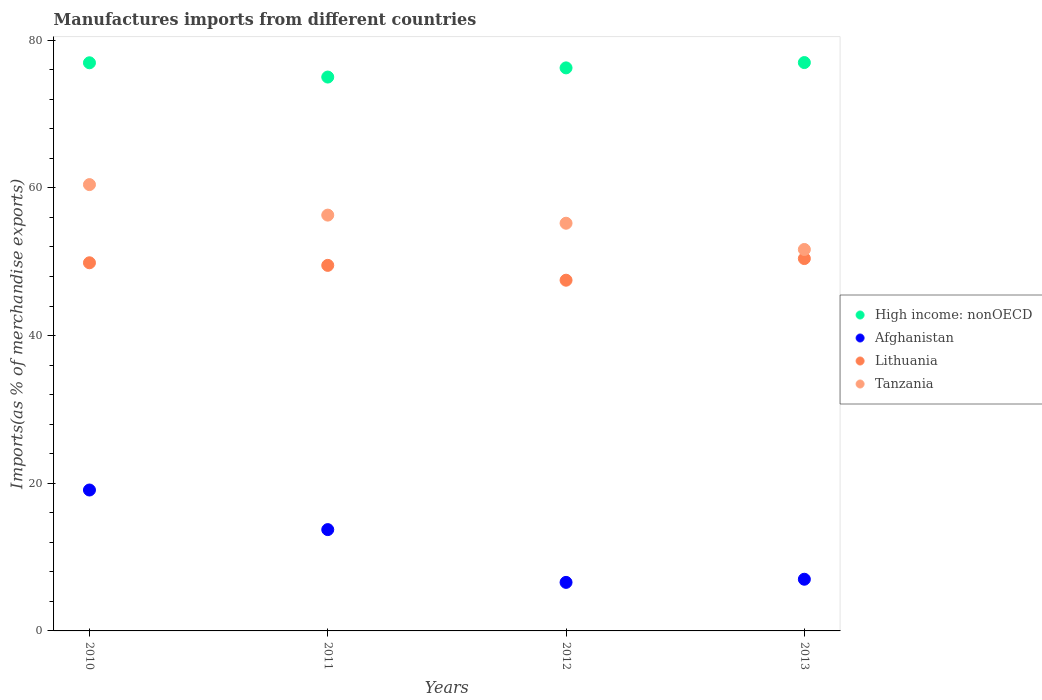How many different coloured dotlines are there?
Provide a succinct answer. 4. What is the percentage of imports to different countries in Afghanistan in 2010?
Provide a short and direct response. 19.08. Across all years, what is the maximum percentage of imports to different countries in Lithuania?
Your response must be concise. 50.43. Across all years, what is the minimum percentage of imports to different countries in Tanzania?
Offer a very short reply. 51.66. In which year was the percentage of imports to different countries in High income: nonOECD maximum?
Offer a terse response. 2013. What is the total percentage of imports to different countries in High income: nonOECD in the graph?
Ensure brevity in your answer.  305.17. What is the difference between the percentage of imports to different countries in Tanzania in 2012 and that in 2013?
Provide a succinct answer. 3.55. What is the difference between the percentage of imports to different countries in High income: nonOECD in 2011 and the percentage of imports to different countries in Afghanistan in 2010?
Give a very brief answer. 55.92. What is the average percentage of imports to different countries in High income: nonOECD per year?
Give a very brief answer. 76.29. In the year 2011, what is the difference between the percentage of imports to different countries in Lithuania and percentage of imports to different countries in High income: nonOECD?
Make the answer very short. -25.5. What is the ratio of the percentage of imports to different countries in Afghanistan in 2010 to that in 2012?
Your answer should be very brief. 2.9. What is the difference between the highest and the second highest percentage of imports to different countries in High income: nonOECD?
Keep it short and to the point. 0.03. What is the difference between the highest and the lowest percentage of imports to different countries in Tanzania?
Make the answer very short. 8.79. Is it the case that in every year, the sum of the percentage of imports to different countries in Lithuania and percentage of imports to different countries in High income: nonOECD  is greater than the sum of percentage of imports to different countries in Tanzania and percentage of imports to different countries in Afghanistan?
Keep it short and to the point. No. Is it the case that in every year, the sum of the percentage of imports to different countries in Lithuania and percentage of imports to different countries in Tanzania  is greater than the percentage of imports to different countries in Afghanistan?
Your answer should be very brief. Yes. Does the percentage of imports to different countries in Lithuania monotonically increase over the years?
Offer a very short reply. No. Is the percentage of imports to different countries in Tanzania strictly greater than the percentage of imports to different countries in High income: nonOECD over the years?
Ensure brevity in your answer.  No. How many dotlines are there?
Keep it short and to the point. 4. How many years are there in the graph?
Provide a short and direct response. 4. Are the values on the major ticks of Y-axis written in scientific E-notation?
Your response must be concise. No. Where does the legend appear in the graph?
Offer a very short reply. Center right. How many legend labels are there?
Your response must be concise. 4. What is the title of the graph?
Make the answer very short. Manufactures imports from different countries. What is the label or title of the Y-axis?
Give a very brief answer. Imports(as % of merchandise exports). What is the Imports(as % of merchandise exports) in High income: nonOECD in 2010?
Give a very brief answer. 76.94. What is the Imports(as % of merchandise exports) of Afghanistan in 2010?
Provide a short and direct response. 19.08. What is the Imports(as % of merchandise exports) in Lithuania in 2010?
Your response must be concise. 49.86. What is the Imports(as % of merchandise exports) in Tanzania in 2010?
Provide a short and direct response. 60.44. What is the Imports(as % of merchandise exports) in High income: nonOECD in 2011?
Make the answer very short. 75.01. What is the Imports(as % of merchandise exports) of Afghanistan in 2011?
Ensure brevity in your answer.  13.72. What is the Imports(as % of merchandise exports) of Lithuania in 2011?
Offer a very short reply. 49.51. What is the Imports(as % of merchandise exports) of Tanzania in 2011?
Make the answer very short. 56.31. What is the Imports(as % of merchandise exports) in High income: nonOECD in 2012?
Offer a terse response. 76.25. What is the Imports(as % of merchandise exports) of Afghanistan in 2012?
Your response must be concise. 6.57. What is the Imports(as % of merchandise exports) in Lithuania in 2012?
Provide a short and direct response. 47.5. What is the Imports(as % of merchandise exports) of Tanzania in 2012?
Ensure brevity in your answer.  55.21. What is the Imports(as % of merchandise exports) of High income: nonOECD in 2013?
Your answer should be very brief. 76.97. What is the Imports(as % of merchandise exports) in Afghanistan in 2013?
Make the answer very short. 7. What is the Imports(as % of merchandise exports) of Lithuania in 2013?
Keep it short and to the point. 50.43. What is the Imports(as % of merchandise exports) of Tanzania in 2013?
Ensure brevity in your answer.  51.66. Across all years, what is the maximum Imports(as % of merchandise exports) of High income: nonOECD?
Your answer should be very brief. 76.97. Across all years, what is the maximum Imports(as % of merchandise exports) of Afghanistan?
Give a very brief answer. 19.08. Across all years, what is the maximum Imports(as % of merchandise exports) in Lithuania?
Your response must be concise. 50.43. Across all years, what is the maximum Imports(as % of merchandise exports) in Tanzania?
Your answer should be very brief. 60.44. Across all years, what is the minimum Imports(as % of merchandise exports) of High income: nonOECD?
Your answer should be very brief. 75.01. Across all years, what is the minimum Imports(as % of merchandise exports) in Afghanistan?
Provide a short and direct response. 6.57. Across all years, what is the minimum Imports(as % of merchandise exports) of Lithuania?
Make the answer very short. 47.5. Across all years, what is the minimum Imports(as % of merchandise exports) in Tanzania?
Keep it short and to the point. 51.66. What is the total Imports(as % of merchandise exports) of High income: nonOECD in the graph?
Ensure brevity in your answer.  305.17. What is the total Imports(as % of merchandise exports) in Afghanistan in the graph?
Keep it short and to the point. 46.38. What is the total Imports(as % of merchandise exports) of Lithuania in the graph?
Your answer should be very brief. 197.28. What is the total Imports(as % of merchandise exports) of Tanzania in the graph?
Your answer should be very brief. 223.62. What is the difference between the Imports(as % of merchandise exports) in High income: nonOECD in 2010 and that in 2011?
Your response must be concise. 1.93. What is the difference between the Imports(as % of merchandise exports) in Afghanistan in 2010 and that in 2011?
Offer a very short reply. 5.36. What is the difference between the Imports(as % of merchandise exports) of Lithuania in 2010 and that in 2011?
Keep it short and to the point. 0.35. What is the difference between the Imports(as % of merchandise exports) of Tanzania in 2010 and that in 2011?
Your response must be concise. 4.13. What is the difference between the Imports(as % of merchandise exports) in High income: nonOECD in 2010 and that in 2012?
Offer a very short reply. 0.69. What is the difference between the Imports(as % of merchandise exports) in Afghanistan in 2010 and that in 2012?
Offer a very short reply. 12.51. What is the difference between the Imports(as % of merchandise exports) of Lithuania in 2010 and that in 2012?
Ensure brevity in your answer.  2.36. What is the difference between the Imports(as % of merchandise exports) in Tanzania in 2010 and that in 2012?
Ensure brevity in your answer.  5.23. What is the difference between the Imports(as % of merchandise exports) of High income: nonOECD in 2010 and that in 2013?
Offer a terse response. -0.03. What is the difference between the Imports(as % of merchandise exports) in Afghanistan in 2010 and that in 2013?
Your response must be concise. 12.08. What is the difference between the Imports(as % of merchandise exports) of Lithuania in 2010 and that in 2013?
Provide a short and direct response. -0.57. What is the difference between the Imports(as % of merchandise exports) of Tanzania in 2010 and that in 2013?
Your response must be concise. 8.79. What is the difference between the Imports(as % of merchandise exports) in High income: nonOECD in 2011 and that in 2012?
Your response must be concise. -1.24. What is the difference between the Imports(as % of merchandise exports) of Afghanistan in 2011 and that in 2012?
Provide a short and direct response. 7.15. What is the difference between the Imports(as % of merchandise exports) of Lithuania in 2011 and that in 2012?
Make the answer very short. 2.01. What is the difference between the Imports(as % of merchandise exports) in Tanzania in 2011 and that in 2012?
Provide a short and direct response. 1.1. What is the difference between the Imports(as % of merchandise exports) of High income: nonOECD in 2011 and that in 2013?
Ensure brevity in your answer.  -1.96. What is the difference between the Imports(as % of merchandise exports) of Afghanistan in 2011 and that in 2013?
Keep it short and to the point. 6.72. What is the difference between the Imports(as % of merchandise exports) in Lithuania in 2011 and that in 2013?
Your answer should be compact. -0.92. What is the difference between the Imports(as % of merchandise exports) in Tanzania in 2011 and that in 2013?
Provide a short and direct response. 4.65. What is the difference between the Imports(as % of merchandise exports) of High income: nonOECD in 2012 and that in 2013?
Give a very brief answer. -0.72. What is the difference between the Imports(as % of merchandise exports) of Afghanistan in 2012 and that in 2013?
Your answer should be compact. -0.43. What is the difference between the Imports(as % of merchandise exports) of Lithuania in 2012 and that in 2013?
Your answer should be very brief. -2.93. What is the difference between the Imports(as % of merchandise exports) of Tanzania in 2012 and that in 2013?
Make the answer very short. 3.55. What is the difference between the Imports(as % of merchandise exports) in High income: nonOECD in 2010 and the Imports(as % of merchandise exports) in Afghanistan in 2011?
Make the answer very short. 63.22. What is the difference between the Imports(as % of merchandise exports) in High income: nonOECD in 2010 and the Imports(as % of merchandise exports) in Lithuania in 2011?
Your answer should be compact. 27.43. What is the difference between the Imports(as % of merchandise exports) of High income: nonOECD in 2010 and the Imports(as % of merchandise exports) of Tanzania in 2011?
Make the answer very short. 20.63. What is the difference between the Imports(as % of merchandise exports) of Afghanistan in 2010 and the Imports(as % of merchandise exports) of Lithuania in 2011?
Your response must be concise. -30.42. What is the difference between the Imports(as % of merchandise exports) of Afghanistan in 2010 and the Imports(as % of merchandise exports) of Tanzania in 2011?
Keep it short and to the point. -37.23. What is the difference between the Imports(as % of merchandise exports) of Lithuania in 2010 and the Imports(as % of merchandise exports) of Tanzania in 2011?
Keep it short and to the point. -6.46. What is the difference between the Imports(as % of merchandise exports) in High income: nonOECD in 2010 and the Imports(as % of merchandise exports) in Afghanistan in 2012?
Offer a very short reply. 70.37. What is the difference between the Imports(as % of merchandise exports) of High income: nonOECD in 2010 and the Imports(as % of merchandise exports) of Lithuania in 2012?
Offer a terse response. 29.44. What is the difference between the Imports(as % of merchandise exports) of High income: nonOECD in 2010 and the Imports(as % of merchandise exports) of Tanzania in 2012?
Give a very brief answer. 21.73. What is the difference between the Imports(as % of merchandise exports) in Afghanistan in 2010 and the Imports(as % of merchandise exports) in Lithuania in 2012?
Ensure brevity in your answer.  -28.41. What is the difference between the Imports(as % of merchandise exports) in Afghanistan in 2010 and the Imports(as % of merchandise exports) in Tanzania in 2012?
Keep it short and to the point. -36.13. What is the difference between the Imports(as % of merchandise exports) of Lithuania in 2010 and the Imports(as % of merchandise exports) of Tanzania in 2012?
Make the answer very short. -5.36. What is the difference between the Imports(as % of merchandise exports) in High income: nonOECD in 2010 and the Imports(as % of merchandise exports) in Afghanistan in 2013?
Offer a very short reply. 69.94. What is the difference between the Imports(as % of merchandise exports) of High income: nonOECD in 2010 and the Imports(as % of merchandise exports) of Lithuania in 2013?
Offer a terse response. 26.51. What is the difference between the Imports(as % of merchandise exports) of High income: nonOECD in 2010 and the Imports(as % of merchandise exports) of Tanzania in 2013?
Keep it short and to the point. 25.28. What is the difference between the Imports(as % of merchandise exports) of Afghanistan in 2010 and the Imports(as % of merchandise exports) of Lithuania in 2013?
Your answer should be compact. -31.34. What is the difference between the Imports(as % of merchandise exports) of Afghanistan in 2010 and the Imports(as % of merchandise exports) of Tanzania in 2013?
Provide a short and direct response. -32.57. What is the difference between the Imports(as % of merchandise exports) in Lithuania in 2010 and the Imports(as % of merchandise exports) in Tanzania in 2013?
Give a very brief answer. -1.8. What is the difference between the Imports(as % of merchandise exports) in High income: nonOECD in 2011 and the Imports(as % of merchandise exports) in Afghanistan in 2012?
Your answer should be very brief. 68.43. What is the difference between the Imports(as % of merchandise exports) in High income: nonOECD in 2011 and the Imports(as % of merchandise exports) in Lithuania in 2012?
Provide a succinct answer. 27.51. What is the difference between the Imports(as % of merchandise exports) of High income: nonOECD in 2011 and the Imports(as % of merchandise exports) of Tanzania in 2012?
Offer a terse response. 19.8. What is the difference between the Imports(as % of merchandise exports) in Afghanistan in 2011 and the Imports(as % of merchandise exports) in Lithuania in 2012?
Your response must be concise. -33.78. What is the difference between the Imports(as % of merchandise exports) in Afghanistan in 2011 and the Imports(as % of merchandise exports) in Tanzania in 2012?
Offer a terse response. -41.49. What is the difference between the Imports(as % of merchandise exports) in Lithuania in 2011 and the Imports(as % of merchandise exports) in Tanzania in 2012?
Make the answer very short. -5.71. What is the difference between the Imports(as % of merchandise exports) in High income: nonOECD in 2011 and the Imports(as % of merchandise exports) in Afghanistan in 2013?
Offer a very short reply. 68.01. What is the difference between the Imports(as % of merchandise exports) in High income: nonOECD in 2011 and the Imports(as % of merchandise exports) in Lithuania in 2013?
Your answer should be compact. 24.58. What is the difference between the Imports(as % of merchandise exports) in High income: nonOECD in 2011 and the Imports(as % of merchandise exports) in Tanzania in 2013?
Ensure brevity in your answer.  23.35. What is the difference between the Imports(as % of merchandise exports) in Afghanistan in 2011 and the Imports(as % of merchandise exports) in Lithuania in 2013?
Your answer should be compact. -36.71. What is the difference between the Imports(as % of merchandise exports) of Afghanistan in 2011 and the Imports(as % of merchandise exports) of Tanzania in 2013?
Make the answer very short. -37.94. What is the difference between the Imports(as % of merchandise exports) in Lithuania in 2011 and the Imports(as % of merchandise exports) in Tanzania in 2013?
Provide a succinct answer. -2.15. What is the difference between the Imports(as % of merchandise exports) of High income: nonOECD in 2012 and the Imports(as % of merchandise exports) of Afghanistan in 2013?
Give a very brief answer. 69.25. What is the difference between the Imports(as % of merchandise exports) in High income: nonOECD in 2012 and the Imports(as % of merchandise exports) in Lithuania in 2013?
Provide a succinct answer. 25.82. What is the difference between the Imports(as % of merchandise exports) in High income: nonOECD in 2012 and the Imports(as % of merchandise exports) in Tanzania in 2013?
Ensure brevity in your answer.  24.59. What is the difference between the Imports(as % of merchandise exports) in Afghanistan in 2012 and the Imports(as % of merchandise exports) in Lithuania in 2013?
Your response must be concise. -43.85. What is the difference between the Imports(as % of merchandise exports) in Afghanistan in 2012 and the Imports(as % of merchandise exports) in Tanzania in 2013?
Your answer should be compact. -45.08. What is the difference between the Imports(as % of merchandise exports) in Lithuania in 2012 and the Imports(as % of merchandise exports) in Tanzania in 2013?
Offer a terse response. -4.16. What is the average Imports(as % of merchandise exports) of High income: nonOECD per year?
Your response must be concise. 76.29. What is the average Imports(as % of merchandise exports) in Afghanistan per year?
Keep it short and to the point. 11.59. What is the average Imports(as % of merchandise exports) of Lithuania per year?
Your answer should be very brief. 49.32. What is the average Imports(as % of merchandise exports) in Tanzania per year?
Provide a short and direct response. 55.91. In the year 2010, what is the difference between the Imports(as % of merchandise exports) of High income: nonOECD and Imports(as % of merchandise exports) of Afghanistan?
Keep it short and to the point. 57.86. In the year 2010, what is the difference between the Imports(as % of merchandise exports) of High income: nonOECD and Imports(as % of merchandise exports) of Lithuania?
Offer a very short reply. 27.08. In the year 2010, what is the difference between the Imports(as % of merchandise exports) in High income: nonOECD and Imports(as % of merchandise exports) in Tanzania?
Offer a terse response. 16.5. In the year 2010, what is the difference between the Imports(as % of merchandise exports) in Afghanistan and Imports(as % of merchandise exports) in Lithuania?
Provide a short and direct response. -30.77. In the year 2010, what is the difference between the Imports(as % of merchandise exports) of Afghanistan and Imports(as % of merchandise exports) of Tanzania?
Your answer should be compact. -41.36. In the year 2010, what is the difference between the Imports(as % of merchandise exports) in Lithuania and Imports(as % of merchandise exports) in Tanzania?
Keep it short and to the point. -10.59. In the year 2011, what is the difference between the Imports(as % of merchandise exports) in High income: nonOECD and Imports(as % of merchandise exports) in Afghanistan?
Your answer should be very brief. 61.29. In the year 2011, what is the difference between the Imports(as % of merchandise exports) in High income: nonOECD and Imports(as % of merchandise exports) in Lithuania?
Keep it short and to the point. 25.5. In the year 2011, what is the difference between the Imports(as % of merchandise exports) in High income: nonOECD and Imports(as % of merchandise exports) in Tanzania?
Give a very brief answer. 18.7. In the year 2011, what is the difference between the Imports(as % of merchandise exports) of Afghanistan and Imports(as % of merchandise exports) of Lithuania?
Ensure brevity in your answer.  -35.78. In the year 2011, what is the difference between the Imports(as % of merchandise exports) in Afghanistan and Imports(as % of merchandise exports) in Tanzania?
Your answer should be very brief. -42.59. In the year 2011, what is the difference between the Imports(as % of merchandise exports) of Lithuania and Imports(as % of merchandise exports) of Tanzania?
Ensure brevity in your answer.  -6.81. In the year 2012, what is the difference between the Imports(as % of merchandise exports) in High income: nonOECD and Imports(as % of merchandise exports) in Afghanistan?
Offer a very short reply. 69.68. In the year 2012, what is the difference between the Imports(as % of merchandise exports) of High income: nonOECD and Imports(as % of merchandise exports) of Lithuania?
Offer a terse response. 28.75. In the year 2012, what is the difference between the Imports(as % of merchandise exports) of High income: nonOECD and Imports(as % of merchandise exports) of Tanzania?
Offer a terse response. 21.04. In the year 2012, what is the difference between the Imports(as % of merchandise exports) in Afghanistan and Imports(as % of merchandise exports) in Lithuania?
Keep it short and to the point. -40.92. In the year 2012, what is the difference between the Imports(as % of merchandise exports) of Afghanistan and Imports(as % of merchandise exports) of Tanzania?
Offer a terse response. -48.64. In the year 2012, what is the difference between the Imports(as % of merchandise exports) of Lithuania and Imports(as % of merchandise exports) of Tanzania?
Give a very brief answer. -7.72. In the year 2013, what is the difference between the Imports(as % of merchandise exports) of High income: nonOECD and Imports(as % of merchandise exports) of Afghanistan?
Ensure brevity in your answer.  69.97. In the year 2013, what is the difference between the Imports(as % of merchandise exports) of High income: nonOECD and Imports(as % of merchandise exports) of Lithuania?
Ensure brevity in your answer.  26.54. In the year 2013, what is the difference between the Imports(as % of merchandise exports) in High income: nonOECD and Imports(as % of merchandise exports) in Tanzania?
Give a very brief answer. 25.31. In the year 2013, what is the difference between the Imports(as % of merchandise exports) in Afghanistan and Imports(as % of merchandise exports) in Lithuania?
Give a very brief answer. -43.43. In the year 2013, what is the difference between the Imports(as % of merchandise exports) of Afghanistan and Imports(as % of merchandise exports) of Tanzania?
Provide a short and direct response. -44.66. In the year 2013, what is the difference between the Imports(as % of merchandise exports) of Lithuania and Imports(as % of merchandise exports) of Tanzania?
Keep it short and to the point. -1.23. What is the ratio of the Imports(as % of merchandise exports) of High income: nonOECD in 2010 to that in 2011?
Ensure brevity in your answer.  1.03. What is the ratio of the Imports(as % of merchandise exports) in Afghanistan in 2010 to that in 2011?
Provide a succinct answer. 1.39. What is the ratio of the Imports(as % of merchandise exports) in Lithuania in 2010 to that in 2011?
Provide a short and direct response. 1.01. What is the ratio of the Imports(as % of merchandise exports) in Tanzania in 2010 to that in 2011?
Ensure brevity in your answer.  1.07. What is the ratio of the Imports(as % of merchandise exports) in Afghanistan in 2010 to that in 2012?
Your answer should be compact. 2.9. What is the ratio of the Imports(as % of merchandise exports) of Lithuania in 2010 to that in 2012?
Give a very brief answer. 1.05. What is the ratio of the Imports(as % of merchandise exports) in Tanzania in 2010 to that in 2012?
Offer a very short reply. 1.09. What is the ratio of the Imports(as % of merchandise exports) in Afghanistan in 2010 to that in 2013?
Your response must be concise. 2.73. What is the ratio of the Imports(as % of merchandise exports) in Lithuania in 2010 to that in 2013?
Keep it short and to the point. 0.99. What is the ratio of the Imports(as % of merchandise exports) in Tanzania in 2010 to that in 2013?
Provide a succinct answer. 1.17. What is the ratio of the Imports(as % of merchandise exports) of High income: nonOECD in 2011 to that in 2012?
Make the answer very short. 0.98. What is the ratio of the Imports(as % of merchandise exports) of Afghanistan in 2011 to that in 2012?
Offer a very short reply. 2.09. What is the ratio of the Imports(as % of merchandise exports) of Lithuania in 2011 to that in 2012?
Your response must be concise. 1.04. What is the ratio of the Imports(as % of merchandise exports) of Tanzania in 2011 to that in 2012?
Provide a short and direct response. 1.02. What is the ratio of the Imports(as % of merchandise exports) of High income: nonOECD in 2011 to that in 2013?
Your answer should be very brief. 0.97. What is the ratio of the Imports(as % of merchandise exports) in Afghanistan in 2011 to that in 2013?
Offer a very short reply. 1.96. What is the ratio of the Imports(as % of merchandise exports) in Lithuania in 2011 to that in 2013?
Provide a short and direct response. 0.98. What is the ratio of the Imports(as % of merchandise exports) in Tanzania in 2011 to that in 2013?
Provide a succinct answer. 1.09. What is the ratio of the Imports(as % of merchandise exports) of High income: nonOECD in 2012 to that in 2013?
Your answer should be very brief. 0.99. What is the ratio of the Imports(as % of merchandise exports) in Afghanistan in 2012 to that in 2013?
Your answer should be compact. 0.94. What is the ratio of the Imports(as % of merchandise exports) of Lithuania in 2012 to that in 2013?
Ensure brevity in your answer.  0.94. What is the ratio of the Imports(as % of merchandise exports) in Tanzania in 2012 to that in 2013?
Your answer should be very brief. 1.07. What is the difference between the highest and the second highest Imports(as % of merchandise exports) of High income: nonOECD?
Offer a terse response. 0.03. What is the difference between the highest and the second highest Imports(as % of merchandise exports) in Afghanistan?
Offer a terse response. 5.36. What is the difference between the highest and the second highest Imports(as % of merchandise exports) in Lithuania?
Your response must be concise. 0.57. What is the difference between the highest and the second highest Imports(as % of merchandise exports) of Tanzania?
Ensure brevity in your answer.  4.13. What is the difference between the highest and the lowest Imports(as % of merchandise exports) of High income: nonOECD?
Give a very brief answer. 1.96. What is the difference between the highest and the lowest Imports(as % of merchandise exports) in Afghanistan?
Your answer should be compact. 12.51. What is the difference between the highest and the lowest Imports(as % of merchandise exports) in Lithuania?
Your answer should be very brief. 2.93. What is the difference between the highest and the lowest Imports(as % of merchandise exports) in Tanzania?
Your answer should be very brief. 8.79. 